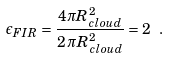<formula> <loc_0><loc_0><loc_500><loc_500>\epsilon _ { F I R } = \frac { 4 \pi R _ { c l o u d } ^ { 2 } } { 2 \, \pi R _ { c l o u d } ^ { 2 } } = 2 \ .</formula> 